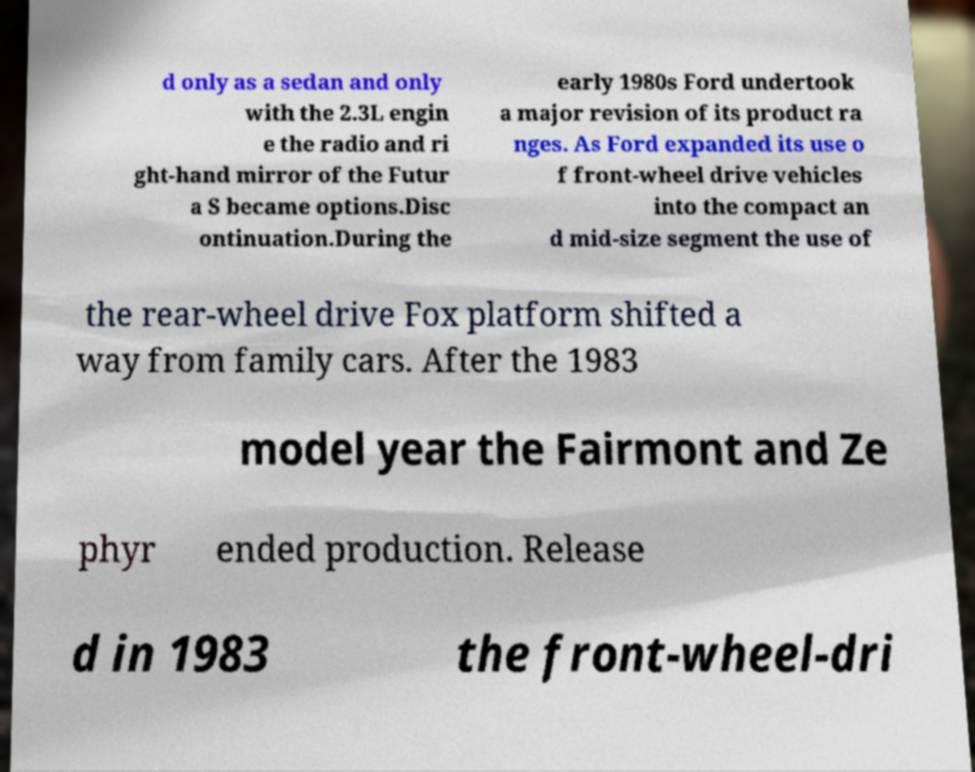What messages or text are displayed in this image? I need them in a readable, typed format. d only as a sedan and only with the 2.3L engin e the radio and ri ght-hand mirror of the Futur a S became options.Disc ontinuation.During the early 1980s Ford undertook a major revision of its product ra nges. As Ford expanded its use o f front-wheel drive vehicles into the compact an d mid-size segment the use of the rear-wheel drive Fox platform shifted a way from family cars. After the 1983 model year the Fairmont and Ze phyr ended production. Release d in 1983 the front-wheel-dri 